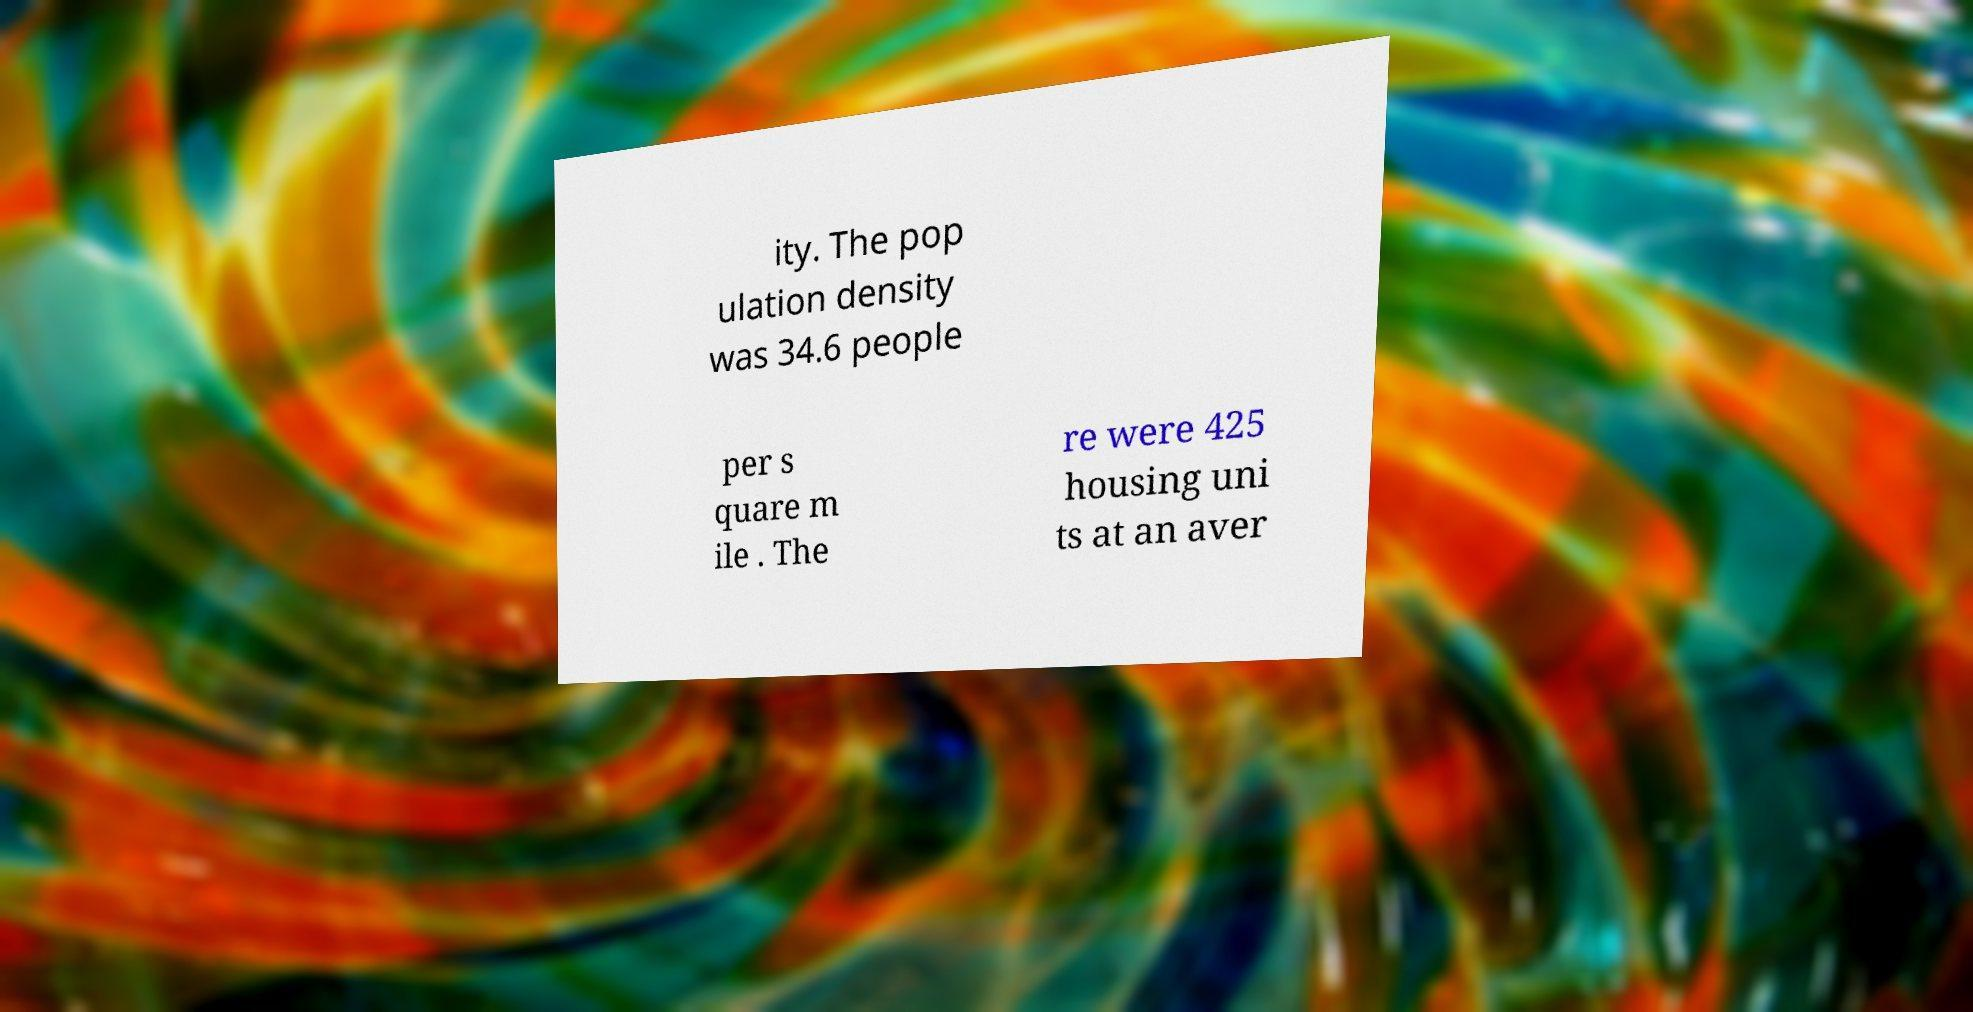Could you extract and type out the text from this image? ity. The pop ulation density was 34.6 people per s quare m ile . The re were 425 housing uni ts at an aver 